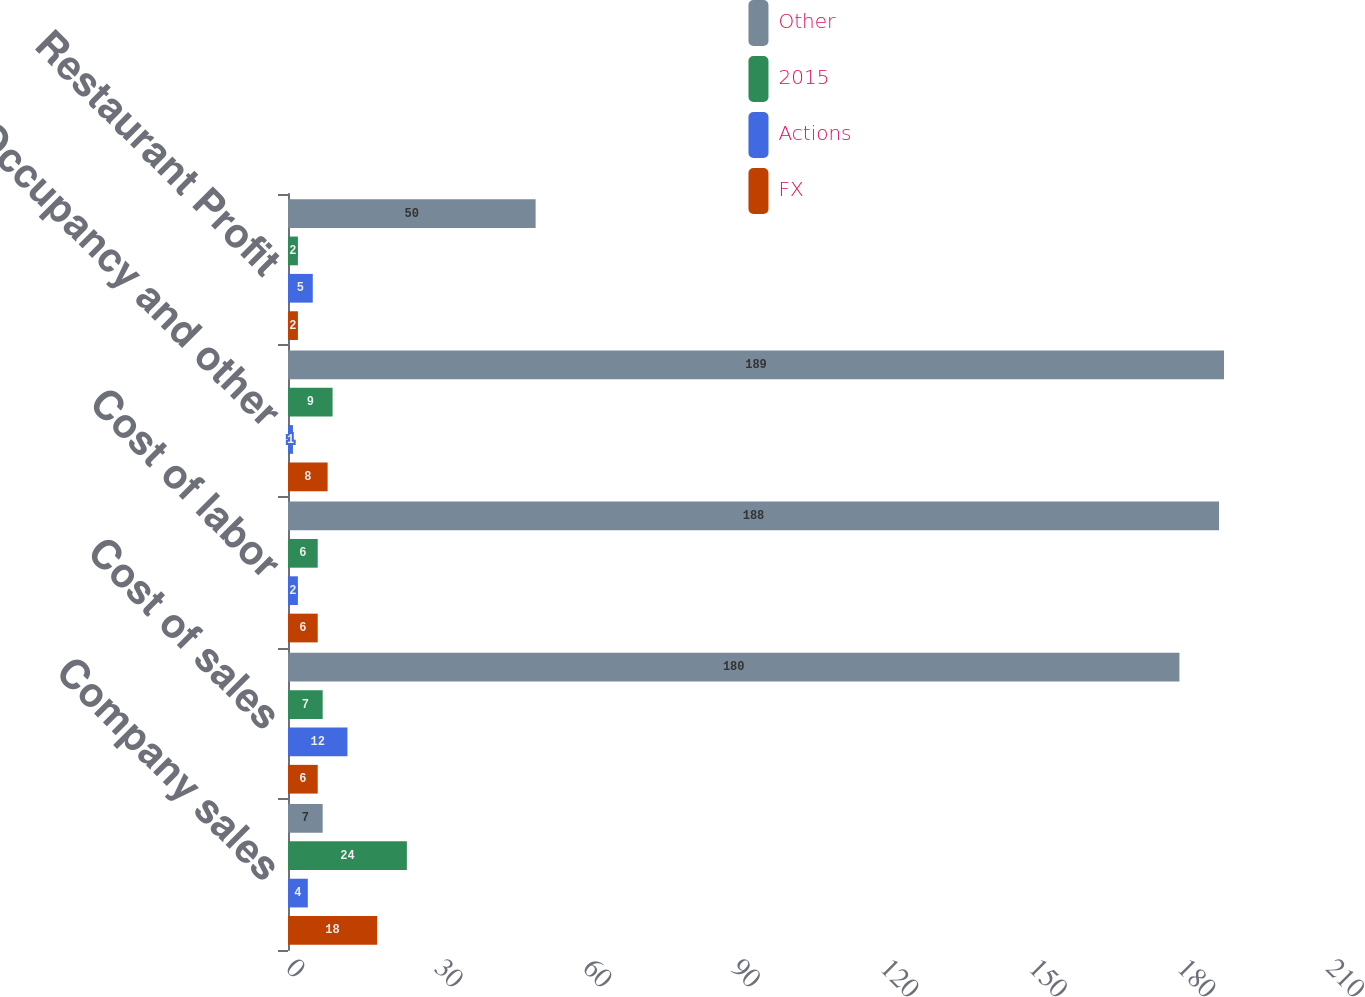Convert chart. <chart><loc_0><loc_0><loc_500><loc_500><stacked_bar_chart><ecel><fcel>Company sales<fcel>Cost of sales<fcel>Cost of labor<fcel>Occupancy and other<fcel>Restaurant Profit<nl><fcel>Other<fcel>7<fcel>180<fcel>188<fcel>189<fcel>50<nl><fcel>2015<fcel>24<fcel>7<fcel>6<fcel>9<fcel>2<nl><fcel>Actions<fcel>4<fcel>12<fcel>2<fcel>1<fcel>5<nl><fcel>FX<fcel>18<fcel>6<fcel>6<fcel>8<fcel>2<nl></chart> 